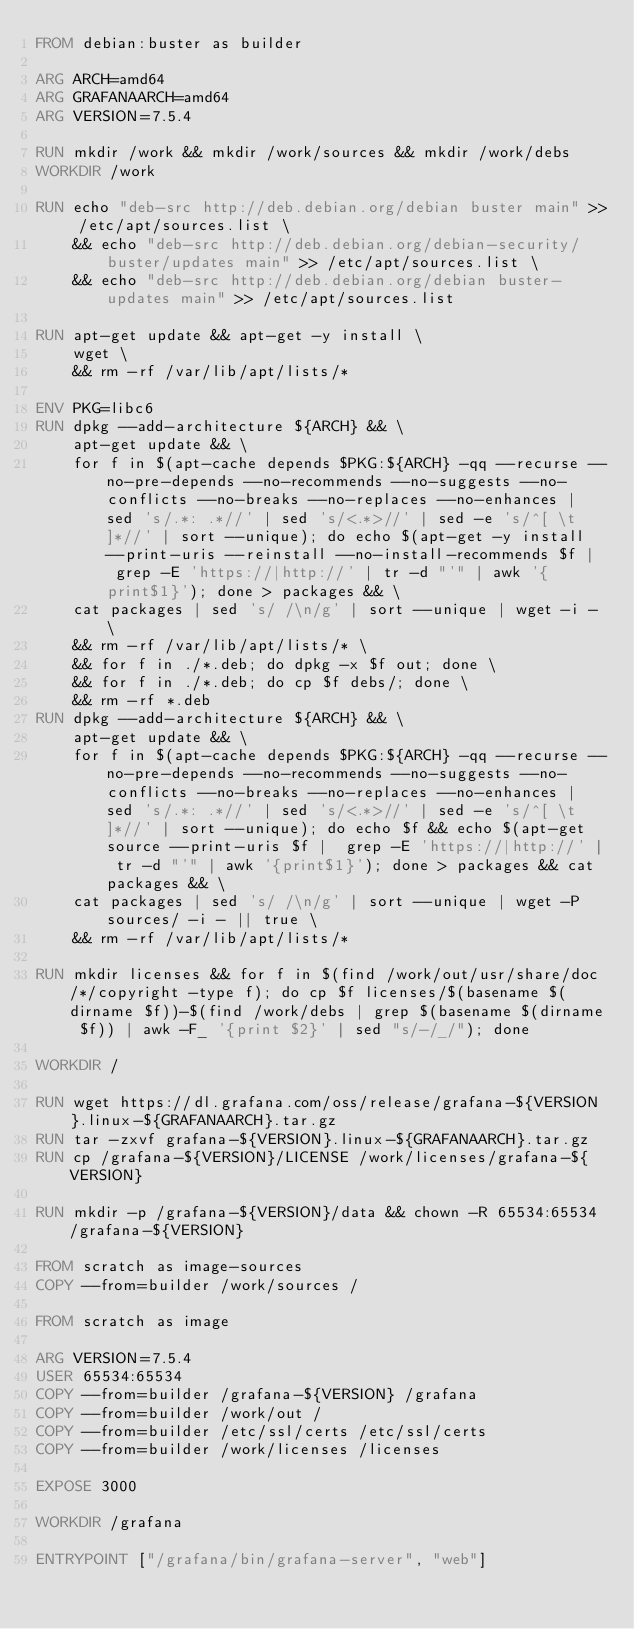<code> <loc_0><loc_0><loc_500><loc_500><_Dockerfile_>FROM debian:buster as builder

ARG ARCH=amd64
ARG GRAFANAARCH=amd64
ARG VERSION=7.5.4

RUN mkdir /work && mkdir /work/sources && mkdir /work/debs
WORKDIR /work

RUN echo "deb-src http://deb.debian.org/debian buster main" >> /etc/apt/sources.list \
    && echo "deb-src http://deb.debian.org/debian-security/ buster/updates main" >> /etc/apt/sources.list \
    && echo "deb-src http://deb.debian.org/debian buster-updates main" >> /etc/apt/sources.list

RUN apt-get update && apt-get -y install \
    wget \
    && rm -rf /var/lib/apt/lists/*
    
ENV PKG=libc6
RUN dpkg --add-architecture ${ARCH} && \
    apt-get update && \
    for f in $(apt-cache depends $PKG:${ARCH} -qq --recurse --no-pre-depends --no-recommends --no-suggests --no-conflicts --no-breaks --no-replaces --no-enhances | sed 's/.*: .*//' | sed 's/<.*>//' | sed -e 's/^[ \t]*//' | sort --unique); do echo $(apt-get -y install --print-uris --reinstall --no-install-recommends $f |  grep -E 'https://|http://' | tr -d "'" | awk '{print$1}'); done > packages && \
    cat packages | sed 's/ /\n/g' | sort --unique | wget -i - \
    && rm -rf /var/lib/apt/lists/* \
    && for f in ./*.deb; do dpkg -x $f out; done \
    && for f in ./*.deb; do cp $f debs/; done \
    && rm -rf *.deb
RUN dpkg --add-architecture ${ARCH} && \
    apt-get update && \
    for f in $(apt-cache depends $PKG:${ARCH} -qq --recurse --no-pre-depends --no-recommends --no-suggests --no-conflicts --no-breaks --no-replaces --no-enhances | sed 's/.*: .*//' | sed 's/<.*>//' | sed -e 's/^[ \t]*//' | sort --unique); do echo $f && echo $(apt-get source --print-uris $f |  grep -E 'https://|http://' | tr -d "'" | awk '{print$1}'); done > packages && cat packages && \
    cat packages | sed 's/ /\n/g' | sort --unique | wget -P sources/ -i - || true \
    && rm -rf /var/lib/apt/lists/*
        
RUN mkdir licenses && for f in $(find /work/out/usr/share/doc/*/copyright -type f); do cp $f licenses/$(basename $(dirname $f))-$(find /work/debs | grep $(basename $(dirname $f)) | awk -F_ '{print $2}' | sed "s/-/_/"); done

WORKDIR /

RUN wget https://dl.grafana.com/oss/release/grafana-${VERSION}.linux-${GRAFANAARCH}.tar.gz
RUN tar -zxvf grafana-${VERSION}.linux-${GRAFANAARCH}.tar.gz
RUN cp /grafana-${VERSION}/LICENSE /work/licenses/grafana-${VERSION}

RUN mkdir -p /grafana-${VERSION}/data && chown -R 65534:65534 /grafana-${VERSION}

FROM scratch as image-sources
COPY --from=builder /work/sources /

FROM scratch as image

ARG VERSION=7.5.4
USER 65534:65534
COPY --from=builder /grafana-${VERSION} /grafana
COPY --from=builder /work/out /
COPY --from=builder /etc/ssl/certs /etc/ssl/certs
COPY --from=builder /work/licenses /licenses

EXPOSE 3000

WORKDIR /grafana

ENTRYPOINT ["/grafana/bin/grafana-server", "web"]
</code> 